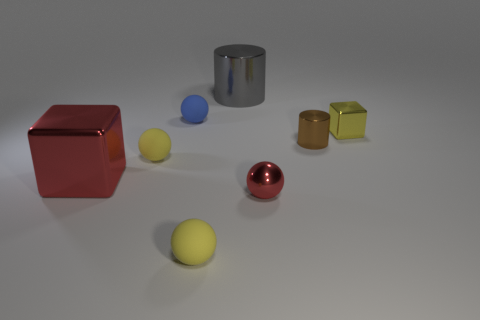There is a object that is the same color as the small metal sphere; what material is it?
Ensure brevity in your answer.  Metal. What size is the shiny cylinder behind the small rubber thing that is behind the small yellow metallic object?
Your response must be concise. Large. Are there any big green balls made of the same material as the tiny brown cylinder?
Your response must be concise. No. There is a blue object that is the same size as the yellow cube; what is its material?
Give a very brief answer. Rubber. Does the metallic cube that is to the left of the small cylinder have the same color as the matte sphere left of the blue rubber ball?
Your answer should be compact. No. Are there any rubber objects to the right of the big metal object behind the small blue sphere?
Keep it short and to the point. No. Do the yellow rubber thing that is behind the big red metal block and the metal thing to the left of the large cylinder have the same shape?
Give a very brief answer. No. Is the material of the cylinder behind the tiny brown cylinder the same as the block that is behind the large red cube?
Keep it short and to the point. Yes. There is a block that is to the right of the big metal thing on the left side of the gray object; what is it made of?
Offer a very short reply. Metal. There is a red object behind the red shiny sphere that is right of the cylinder that is behind the small brown metal cylinder; what shape is it?
Make the answer very short. Cube. 